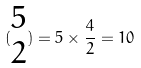Convert formula to latex. <formula><loc_0><loc_0><loc_500><loc_500>( \begin{matrix} 5 \\ 2 \end{matrix} ) = 5 \times \frac { 4 } { 2 } = 1 0</formula> 